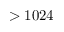Convert formula to latex. <formula><loc_0><loc_0><loc_500><loc_500>> 1 0 2 4</formula> 